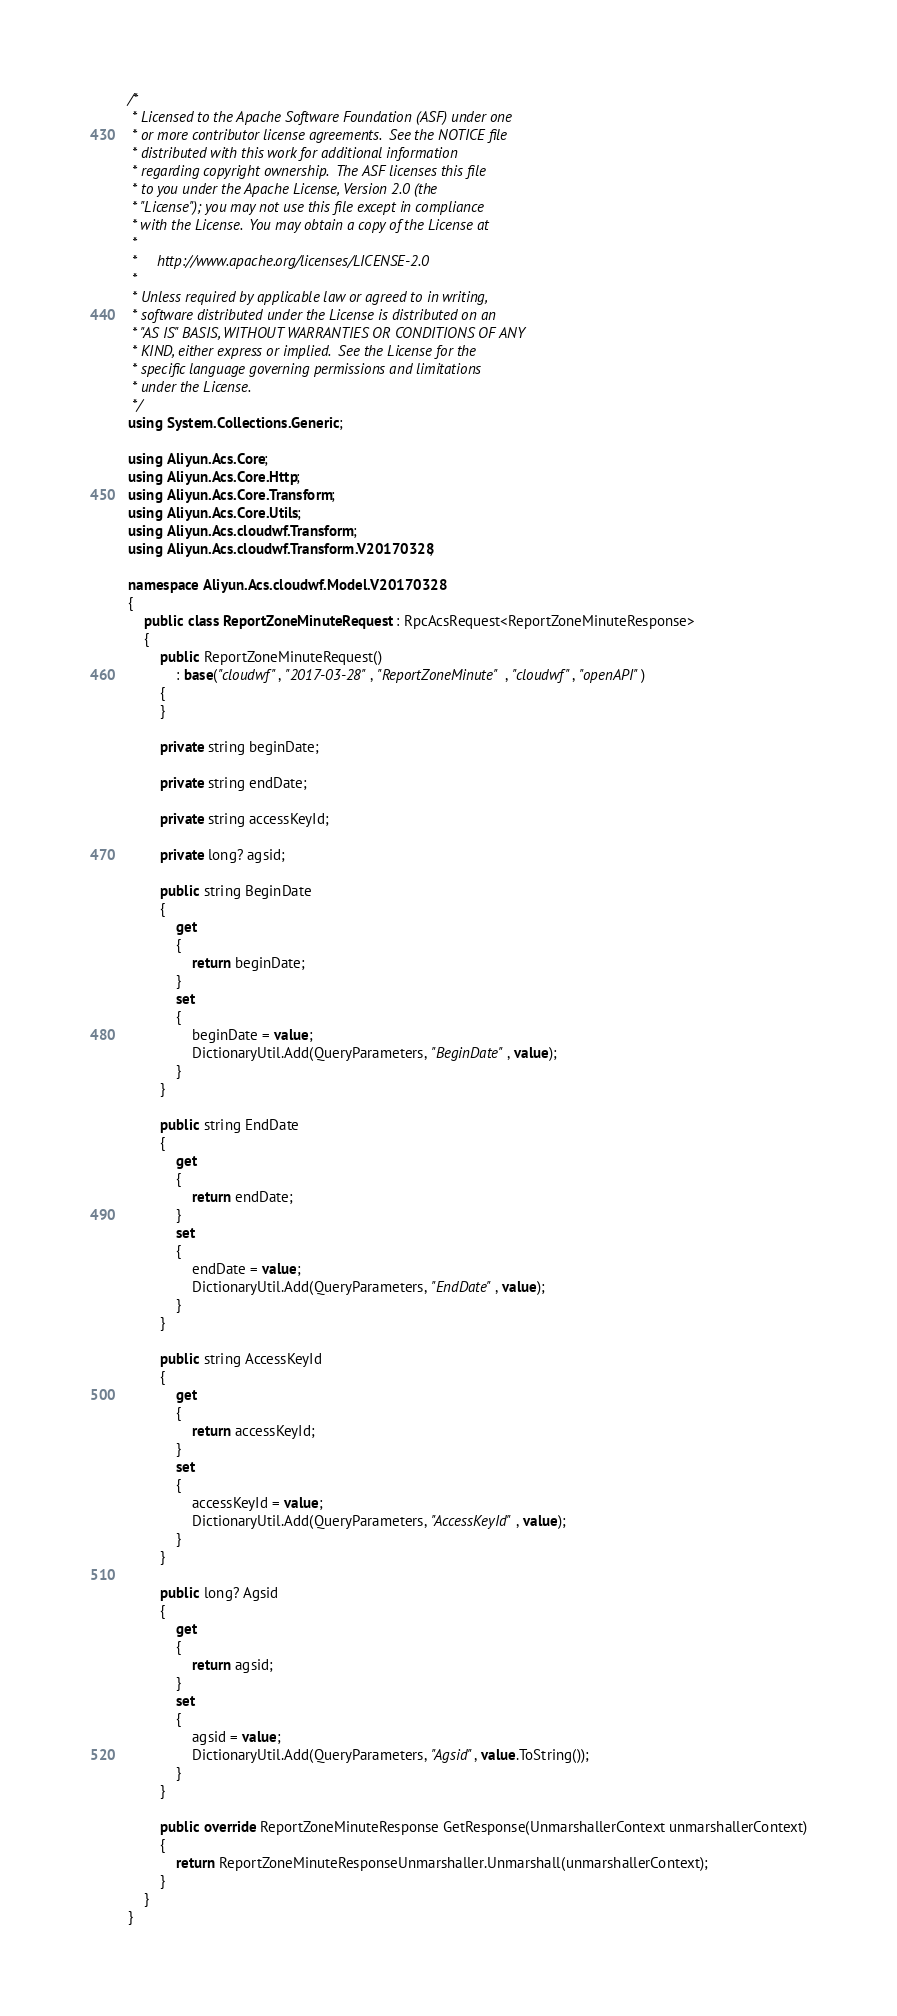Convert code to text. <code><loc_0><loc_0><loc_500><loc_500><_C#_>/*
 * Licensed to the Apache Software Foundation (ASF) under one
 * or more contributor license agreements.  See the NOTICE file
 * distributed with this work for additional information
 * regarding copyright ownership.  The ASF licenses this file
 * to you under the Apache License, Version 2.0 (the
 * "License"); you may not use this file except in compliance
 * with the License.  You may obtain a copy of the License at
 *
 *     http://www.apache.org/licenses/LICENSE-2.0
 *
 * Unless required by applicable law or agreed to in writing,
 * software distributed under the License is distributed on an
 * "AS IS" BASIS, WITHOUT WARRANTIES OR CONDITIONS OF ANY
 * KIND, either express or implied.  See the License for the
 * specific language governing permissions and limitations
 * under the License.
 */
using System.Collections.Generic;

using Aliyun.Acs.Core;
using Aliyun.Acs.Core.Http;
using Aliyun.Acs.Core.Transform;
using Aliyun.Acs.Core.Utils;
using Aliyun.Acs.cloudwf.Transform;
using Aliyun.Acs.cloudwf.Transform.V20170328;

namespace Aliyun.Acs.cloudwf.Model.V20170328
{
    public class ReportZoneMinuteRequest : RpcAcsRequest<ReportZoneMinuteResponse>
    {
        public ReportZoneMinuteRequest()
            : base("cloudwf", "2017-03-28", "ReportZoneMinute", "cloudwf", "openAPI")
        {
        }

		private string beginDate;

		private string endDate;

		private string accessKeyId;

		private long? agsid;

		public string BeginDate
		{
			get
			{
				return beginDate;
			}
			set	
			{
				beginDate = value;
				DictionaryUtil.Add(QueryParameters, "BeginDate", value);
			}
		}

		public string EndDate
		{
			get
			{
				return endDate;
			}
			set	
			{
				endDate = value;
				DictionaryUtil.Add(QueryParameters, "EndDate", value);
			}
		}

		public string AccessKeyId
		{
			get
			{
				return accessKeyId;
			}
			set	
			{
				accessKeyId = value;
				DictionaryUtil.Add(QueryParameters, "AccessKeyId", value);
			}
		}

		public long? Agsid
		{
			get
			{
				return agsid;
			}
			set	
			{
				agsid = value;
				DictionaryUtil.Add(QueryParameters, "Agsid", value.ToString());
			}
		}

        public override ReportZoneMinuteResponse GetResponse(UnmarshallerContext unmarshallerContext)
        {
            return ReportZoneMinuteResponseUnmarshaller.Unmarshall(unmarshallerContext);
        }
    }
}
</code> 